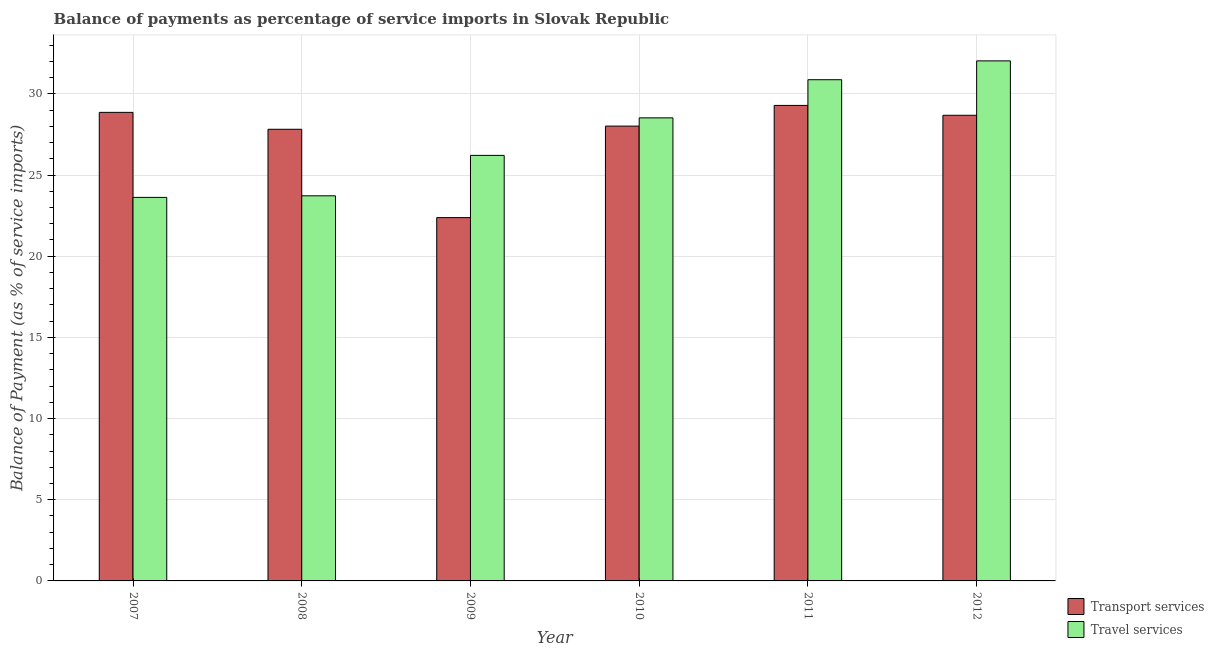Are the number of bars on each tick of the X-axis equal?
Make the answer very short. Yes. How many bars are there on the 2nd tick from the left?
Offer a terse response. 2. What is the label of the 1st group of bars from the left?
Keep it short and to the point. 2007. What is the balance of payments of travel services in 2012?
Provide a short and direct response. 32.03. Across all years, what is the maximum balance of payments of travel services?
Keep it short and to the point. 32.03. Across all years, what is the minimum balance of payments of travel services?
Provide a succinct answer. 23.62. In which year was the balance of payments of transport services minimum?
Keep it short and to the point. 2009. What is the total balance of payments of travel services in the graph?
Provide a succinct answer. 164.97. What is the difference between the balance of payments of travel services in 2007 and that in 2012?
Your answer should be compact. -8.41. What is the difference between the balance of payments of transport services in 2012 and the balance of payments of travel services in 2009?
Make the answer very short. 6.3. What is the average balance of payments of transport services per year?
Provide a short and direct response. 27.51. What is the ratio of the balance of payments of transport services in 2007 to that in 2008?
Provide a succinct answer. 1.04. Is the balance of payments of transport services in 2009 less than that in 2011?
Your answer should be compact. Yes. What is the difference between the highest and the second highest balance of payments of travel services?
Keep it short and to the point. 1.16. What is the difference between the highest and the lowest balance of payments of transport services?
Offer a very short reply. 6.91. In how many years, is the balance of payments of transport services greater than the average balance of payments of transport services taken over all years?
Offer a very short reply. 5. What does the 1st bar from the left in 2011 represents?
Ensure brevity in your answer.  Transport services. What does the 1st bar from the right in 2008 represents?
Your answer should be very brief. Travel services. How many bars are there?
Your response must be concise. 12. Are the values on the major ticks of Y-axis written in scientific E-notation?
Offer a terse response. No. How are the legend labels stacked?
Make the answer very short. Vertical. What is the title of the graph?
Your answer should be very brief. Balance of payments as percentage of service imports in Slovak Republic. Does "Non-pregnant women" appear as one of the legend labels in the graph?
Keep it short and to the point. No. What is the label or title of the X-axis?
Give a very brief answer. Year. What is the label or title of the Y-axis?
Your answer should be compact. Balance of Payment (as % of service imports). What is the Balance of Payment (as % of service imports) in Transport services in 2007?
Offer a terse response. 28.86. What is the Balance of Payment (as % of service imports) in Travel services in 2007?
Offer a terse response. 23.62. What is the Balance of Payment (as % of service imports) in Transport services in 2008?
Offer a very short reply. 27.82. What is the Balance of Payment (as % of service imports) of Travel services in 2008?
Ensure brevity in your answer.  23.72. What is the Balance of Payment (as % of service imports) of Transport services in 2009?
Your response must be concise. 22.38. What is the Balance of Payment (as % of service imports) of Travel services in 2009?
Offer a very short reply. 26.21. What is the Balance of Payment (as % of service imports) in Transport services in 2010?
Keep it short and to the point. 28.01. What is the Balance of Payment (as % of service imports) of Travel services in 2010?
Provide a succinct answer. 28.52. What is the Balance of Payment (as % of service imports) of Transport services in 2011?
Offer a terse response. 29.29. What is the Balance of Payment (as % of service imports) in Travel services in 2011?
Offer a very short reply. 30.87. What is the Balance of Payment (as % of service imports) in Transport services in 2012?
Offer a very short reply. 28.68. What is the Balance of Payment (as % of service imports) in Travel services in 2012?
Provide a succinct answer. 32.03. Across all years, what is the maximum Balance of Payment (as % of service imports) of Transport services?
Make the answer very short. 29.29. Across all years, what is the maximum Balance of Payment (as % of service imports) of Travel services?
Ensure brevity in your answer.  32.03. Across all years, what is the minimum Balance of Payment (as % of service imports) of Transport services?
Offer a very short reply. 22.38. Across all years, what is the minimum Balance of Payment (as % of service imports) in Travel services?
Your answer should be very brief. 23.62. What is the total Balance of Payment (as % of service imports) in Transport services in the graph?
Ensure brevity in your answer.  165.03. What is the total Balance of Payment (as % of service imports) of Travel services in the graph?
Keep it short and to the point. 164.97. What is the difference between the Balance of Payment (as % of service imports) of Transport services in 2007 and that in 2008?
Your response must be concise. 1.04. What is the difference between the Balance of Payment (as % of service imports) of Travel services in 2007 and that in 2008?
Your response must be concise. -0.1. What is the difference between the Balance of Payment (as % of service imports) of Transport services in 2007 and that in 2009?
Offer a very short reply. 6.48. What is the difference between the Balance of Payment (as % of service imports) of Travel services in 2007 and that in 2009?
Your answer should be very brief. -2.59. What is the difference between the Balance of Payment (as % of service imports) of Transport services in 2007 and that in 2010?
Ensure brevity in your answer.  0.85. What is the difference between the Balance of Payment (as % of service imports) of Travel services in 2007 and that in 2010?
Make the answer very short. -4.9. What is the difference between the Balance of Payment (as % of service imports) in Transport services in 2007 and that in 2011?
Keep it short and to the point. -0.43. What is the difference between the Balance of Payment (as % of service imports) of Travel services in 2007 and that in 2011?
Your answer should be compact. -7.25. What is the difference between the Balance of Payment (as % of service imports) of Transport services in 2007 and that in 2012?
Give a very brief answer. 0.18. What is the difference between the Balance of Payment (as % of service imports) in Travel services in 2007 and that in 2012?
Give a very brief answer. -8.41. What is the difference between the Balance of Payment (as % of service imports) of Transport services in 2008 and that in 2009?
Give a very brief answer. 5.44. What is the difference between the Balance of Payment (as % of service imports) in Travel services in 2008 and that in 2009?
Ensure brevity in your answer.  -2.49. What is the difference between the Balance of Payment (as % of service imports) of Transport services in 2008 and that in 2010?
Make the answer very short. -0.2. What is the difference between the Balance of Payment (as % of service imports) in Travel services in 2008 and that in 2010?
Your answer should be very brief. -4.8. What is the difference between the Balance of Payment (as % of service imports) in Transport services in 2008 and that in 2011?
Make the answer very short. -1.47. What is the difference between the Balance of Payment (as % of service imports) in Travel services in 2008 and that in 2011?
Provide a succinct answer. -7.15. What is the difference between the Balance of Payment (as % of service imports) of Transport services in 2008 and that in 2012?
Your answer should be very brief. -0.86. What is the difference between the Balance of Payment (as % of service imports) in Travel services in 2008 and that in 2012?
Your answer should be very brief. -8.31. What is the difference between the Balance of Payment (as % of service imports) of Transport services in 2009 and that in 2010?
Make the answer very short. -5.64. What is the difference between the Balance of Payment (as % of service imports) of Travel services in 2009 and that in 2010?
Give a very brief answer. -2.31. What is the difference between the Balance of Payment (as % of service imports) of Transport services in 2009 and that in 2011?
Offer a terse response. -6.91. What is the difference between the Balance of Payment (as % of service imports) of Travel services in 2009 and that in 2011?
Offer a terse response. -4.66. What is the difference between the Balance of Payment (as % of service imports) of Transport services in 2009 and that in 2012?
Your response must be concise. -6.3. What is the difference between the Balance of Payment (as % of service imports) of Travel services in 2009 and that in 2012?
Provide a short and direct response. -5.82. What is the difference between the Balance of Payment (as % of service imports) of Transport services in 2010 and that in 2011?
Your answer should be compact. -1.27. What is the difference between the Balance of Payment (as % of service imports) in Travel services in 2010 and that in 2011?
Your answer should be compact. -2.35. What is the difference between the Balance of Payment (as % of service imports) of Transport services in 2010 and that in 2012?
Offer a terse response. -0.67. What is the difference between the Balance of Payment (as % of service imports) of Travel services in 2010 and that in 2012?
Your response must be concise. -3.51. What is the difference between the Balance of Payment (as % of service imports) in Transport services in 2011 and that in 2012?
Make the answer very short. 0.61. What is the difference between the Balance of Payment (as % of service imports) of Travel services in 2011 and that in 2012?
Offer a terse response. -1.16. What is the difference between the Balance of Payment (as % of service imports) of Transport services in 2007 and the Balance of Payment (as % of service imports) of Travel services in 2008?
Your answer should be compact. 5.14. What is the difference between the Balance of Payment (as % of service imports) in Transport services in 2007 and the Balance of Payment (as % of service imports) in Travel services in 2009?
Offer a very short reply. 2.65. What is the difference between the Balance of Payment (as % of service imports) in Transport services in 2007 and the Balance of Payment (as % of service imports) in Travel services in 2010?
Give a very brief answer. 0.34. What is the difference between the Balance of Payment (as % of service imports) in Transport services in 2007 and the Balance of Payment (as % of service imports) in Travel services in 2011?
Give a very brief answer. -2.01. What is the difference between the Balance of Payment (as % of service imports) of Transport services in 2007 and the Balance of Payment (as % of service imports) of Travel services in 2012?
Your answer should be very brief. -3.17. What is the difference between the Balance of Payment (as % of service imports) of Transport services in 2008 and the Balance of Payment (as % of service imports) of Travel services in 2009?
Ensure brevity in your answer.  1.61. What is the difference between the Balance of Payment (as % of service imports) of Transport services in 2008 and the Balance of Payment (as % of service imports) of Travel services in 2010?
Your response must be concise. -0.7. What is the difference between the Balance of Payment (as % of service imports) of Transport services in 2008 and the Balance of Payment (as % of service imports) of Travel services in 2011?
Provide a succinct answer. -3.05. What is the difference between the Balance of Payment (as % of service imports) in Transport services in 2008 and the Balance of Payment (as % of service imports) in Travel services in 2012?
Give a very brief answer. -4.21. What is the difference between the Balance of Payment (as % of service imports) of Transport services in 2009 and the Balance of Payment (as % of service imports) of Travel services in 2010?
Your answer should be compact. -6.14. What is the difference between the Balance of Payment (as % of service imports) in Transport services in 2009 and the Balance of Payment (as % of service imports) in Travel services in 2011?
Your response must be concise. -8.49. What is the difference between the Balance of Payment (as % of service imports) in Transport services in 2009 and the Balance of Payment (as % of service imports) in Travel services in 2012?
Your answer should be very brief. -9.65. What is the difference between the Balance of Payment (as % of service imports) in Transport services in 2010 and the Balance of Payment (as % of service imports) in Travel services in 2011?
Keep it short and to the point. -2.86. What is the difference between the Balance of Payment (as % of service imports) of Transport services in 2010 and the Balance of Payment (as % of service imports) of Travel services in 2012?
Keep it short and to the point. -4.02. What is the difference between the Balance of Payment (as % of service imports) in Transport services in 2011 and the Balance of Payment (as % of service imports) in Travel services in 2012?
Keep it short and to the point. -2.74. What is the average Balance of Payment (as % of service imports) in Transport services per year?
Your response must be concise. 27.51. What is the average Balance of Payment (as % of service imports) in Travel services per year?
Your response must be concise. 27.5. In the year 2007, what is the difference between the Balance of Payment (as % of service imports) of Transport services and Balance of Payment (as % of service imports) of Travel services?
Offer a very short reply. 5.24. In the year 2008, what is the difference between the Balance of Payment (as % of service imports) of Transport services and Balance of Payment (as % of service imports) of Travel services?
Offer a very short reply. 4.1. In the year 2009, what is the difference between the Balance of Payment (as % of service imports) in Transport services and Balance of Payment (as % of service imports) in Travel services?
Your response must be concise. -3.83. In the year 2010, what is the difference between the Balance of Payment (as % of service imports) in Transport services and Balance of Payment (as % of service imports) in Travel services?
Provide a succinct answer. -0.51. In the year 2011, what is the difference between the Balance of Payment (as % of service imports) in Transport services and Balance of Payment (as % of service imports) in Travel services?
Give a very brief answer. -1.58. In the year 2012, what is the difference between the Balance of Payment (as % of service imports) in Transport services and Balance of Payment (as % of service imports) in Travel services?
Give a very brief answer. -3.35. What is the ratio of the Balance of Payment (as % of service imports) in Transport services in 2007 to that in 2008?
Your answer should be very brief. 1.04. What is the ratio of the Balance of Payment (as % of service imports) of Travel services in 2007 to that in 2008?
Make the answer very short. 1. What is the ratio of the Balance of Payment (as % of service imports) of Transport services in 2007 to that in 2009?
Your answer should be compact. 1.29. What is the ratio of the Balance of Payment (as % of service imports) of Travel services in 2007 to that in 2009?
Your answer should be very brief. 0.9. What is the ratio of the Balance of Payment (as % of service imports) of Transport services in 2007 to that in 2010?
Provide a short and direct response. 1.03. What is the ratio of the Balance of Payment (as % of service imports) in Travel services in 2007 to that in 2010?
Your answer should be very brief. 0.83. What is the ratio of the Balance of Payment (as % of service imports) of Transport services in 2007 to that in 2011?
Make the answer very short. 0.99. What is the ratio of the Balance of Payment (as % of service imports) of Travel services in 2007 to that in 2011?
Ensure brevity in your answer.  0.77. What is the ratio of the Balance of Payment (as % of service imports) in Travel services in 2007 to that in 2012?
Make the answer very short. 0.74. What is the ratio of the Balance of Payment (as % of service imports) of Transport services in 2008 to that in 2009?
Your answer should be compact. 1.24. What is the ratio of the Balance of Payment (as % of service imports) in Travel services in 2008 to that in 2009?
Provide a short and direct response. 0.91. What is the ratio of the Balance of Payment (as % of service imports) in Travel services in 2008 to that in 2010?
Provide a succinct answer. 0.83. What is the ratio of the Balance of Payment (as % of service imports) of Transport services in 2008 to that in 2011?
Ensure brevity in your answer.  0.95. What is the ratio of the Balance of Payment (as % of service imports) of Travel services in 2008 to that in 2011?
Offer a terse response. 0.77. What is the ratio of the Balance of Payment (as % of service imports) in Transport services in 2008 to that in 2012?
Provide a succinct answer. 0.97. What is the ratio of the Balance of Payment (as % of service imports) in Travel services in 2008 to that in 2012?
Ensure brevity in your answer.  0.74. What is the ratio of the Balance of Payment (as % of service imports) of Transport services in 2009 to that in 2010?
Your answer should be very brief. 0.8. What is the ratio of the Balance of Payment (as % of service imports) in Travel services in 2009 to that in 2010?
Offer a terse response. 0.92. What is the ratio of the Balance of Payment (as % of service imports) in Transport services in 2009 to that in 2011?
Your response must be concise. 0.76. What is the ratio of the Balance of Payment (as % of service imports) of Travel services in 2009 to that in 2011?
Keep it short and to the point. 0.85. What is the ratio of the Balance of Payment (as % of service imports) in Transport services in 2009 to that in 2012?
Your answer should be compact. 0.78. What is the ratio of the Balance of Payment (as % of service imports) of Travel services in 2009 to that in 2012?
Offer a very short reply. 0.82. What is the ratio of the Balance of Payment (as % of service imports) of Transport services in 2010 to that in 2011?
Ensure brevity in your answer.  0.96. What is the ratio of the Balance of Payment (as % of service imports) of Travel services in 2010 to that in 2011?
Keep it short and to the point. 0.92. What is the ratio of the Balance of Payment (as % of service imports) of Transport services in 2010 to that in 2012?
Give a very brief answer. 0.98. What is the ratio of the Balance of Payment (as % of service imports) in Travel services in 2010 to that in 2012?
Make the answer very short. 0.89. What is the ratio of the Balance of Payment (as % of service imports) of Transport services in 2011 to that in 2012?
Your response must be concise. 1.02. What is the ratio of the Balance of Payment (as % of service imports) in Travel services in 2011 to that in 2012?
Your response must be concise. 0.96. What is the difference between the highest and the second highest Balance of Payment (as % of service imports) of Transport services?
Offer a terse response. 0.43. What is the difference between the highest and the second highest Balance of Payment (as % of service imports) of Travel services?
Provide a short and direct response. 1.16. What is the difference between the highest and the lowest Balance of Payment (as % of service imports) in Transport services?
Your response must be concise. 6.91. What is the difference between the highest and the lowest Balance of Payment (as % of service imports) in Travel services?
Offer a very short reply. 8.41. 